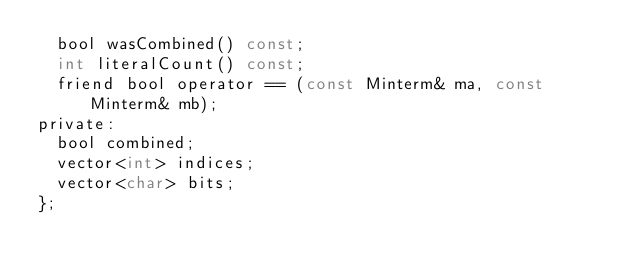<code> <loc_0><loc_0><loc_500><loc_500><_C_>	bool wasCombined() const;
	int literalCount() const;
	friend bool operator == (const Minterm& ma, const Minterm& mb);
private:
	bool combined;
	vector<int> indices;
	vector<char> bits;
};

</code> 